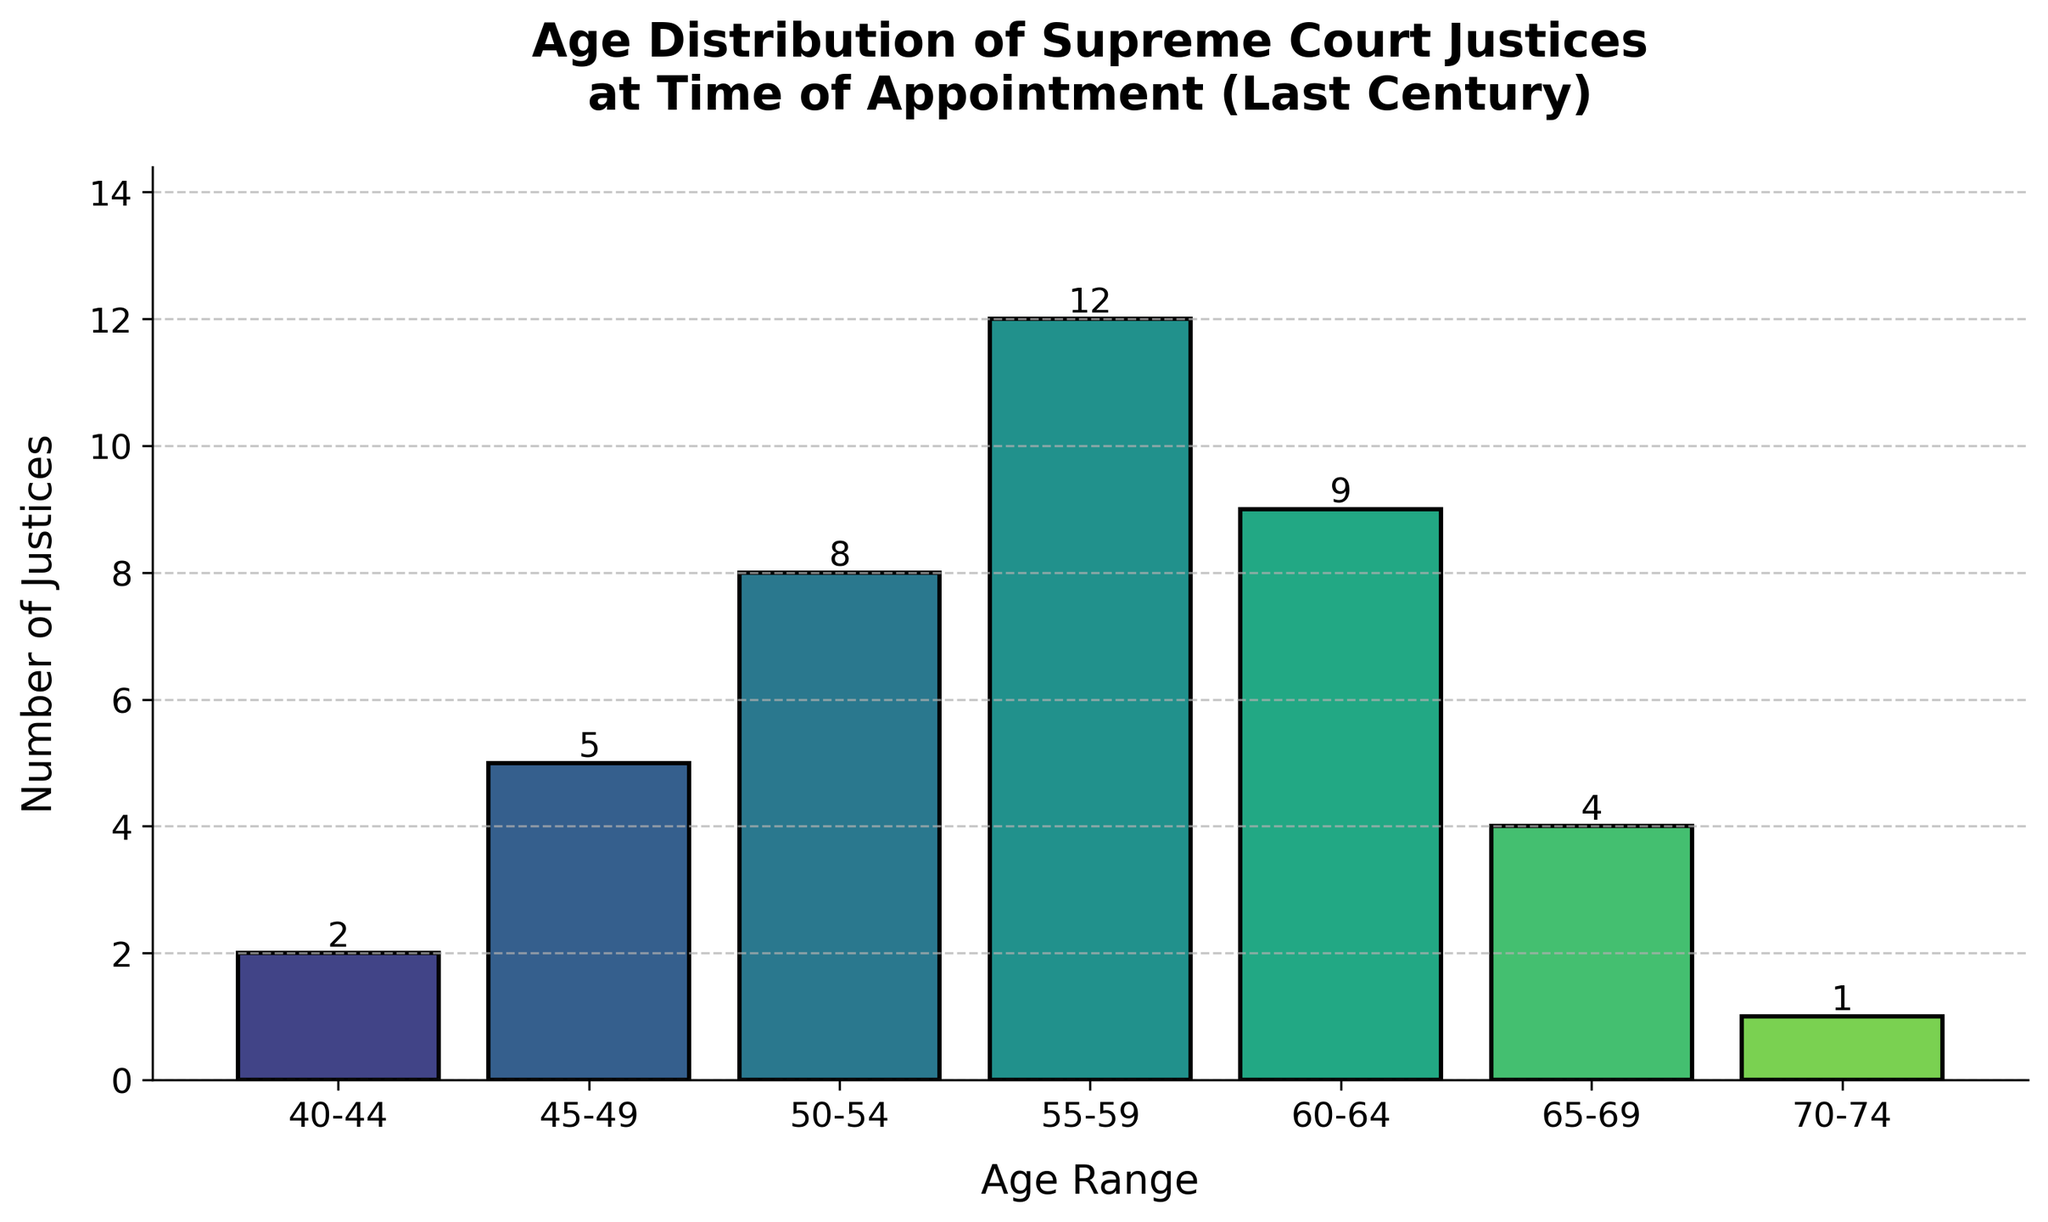what is the most common age range at the time of appointment for Supreme Court justices? The age range with the highest frequency is 55-59, with 12 justices.
Answer: 55-59 How many justices were appointed between the ages of 55 and 64? Count the frequencies for age ranges 55-59 and 60-64. Add 12 (55-59) and 9 (60-64) to get the total number of justices.
Answer: 21 Which age range had the least number of justices appointed? The age range with the lowest frequency is 70-74, with 1 justice.
Answer: 70-74 Compare the number of justices appointed under the age of 50 to those appointed over the age of 65. Sum the frequencies for age ranges 40-44 and 45-49 to get the count for under 50, and 65-69 and 70-74 for over 65. Under 50: 2 + 5 = 7. Over 65: 4 + 1 = 5.
Answer: Under 50: 7, Over 65: 5 What is the age range of the second-highest number of justices appointed? The second-highest frequency is 9, which corresponds to the age range 60-64.
Answer: 60-64 How many justices were appointed between the ages of 40 and 49? Add the frequencies for age ranges 40-44 and 45-49. 2 + 5 = 7.
Answer: 7 What is the total number of justices appointed between the ages of 50 and 69? Add the frequencies for age ranges 50-54, 55-59, 60-64, and 65-69. 8 + 12 + 9 + 4 = 33.
Answer: 33 What age range corresponds to the frequency of 4 justices? The age range with a frequency of 4 is 65-69.
Answer: 65-69 Which age group with justices holds a frequency that matches the median frequency value of all the age groups? The frequency values ordered: 1, 2, 4, 5, 8, 9, 12. The median is 5. The age range with this frequency is 45-49.
Answer: 45-49 How does the number of justices in the age range 60-64 compare to those in the age range 50-54? The frequency for age range 60-64 is 9, while for 50-54 it is 8. Therefore, more justices were appointed in the 60-64 age range.
Answer: 60-64 > 50-54 